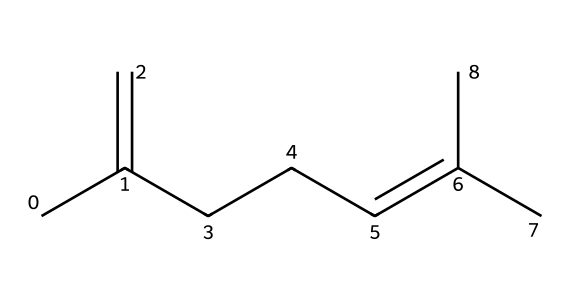What is the molecular formula of the compound? To find the molecular formula, we count the number of carbon (C) and hydrogen (H) atoms in the structure. There are 10 carbon atoms and 16 hydrogen atoms, giving us C10H16.
Answer: C10H16 How many double bonds are present in the chemical? By examining the connections and the presence of '=' symbols in the structure, we see two double bonds are indicated in the chain.
Answer: 2 What type of hydrocarbon is this compound, based on its structure? This chemical contains carbon and hydrogen with at least one double bond and no functional groups typical of alkenes, indicating that it is a type of alkene specifically.
Answer: alkene What is the significance of the carbon chain length in terms of insulation properties? Longer carbon chains can lead to better flexibility and thermal stability, important properties for materials used in electrical insulation. The fact that there are 10 carbon atoms suggests it could provide substantial insulation capabilities.
Answer: flexibility What characteristic of this compound contributes to its use as an insulating material? The presence of the carbon-to-carbon double bonds contributes to the thermal and electrical stability required in insulating materials, allowing them to resist conductivity.
Answer: stability 